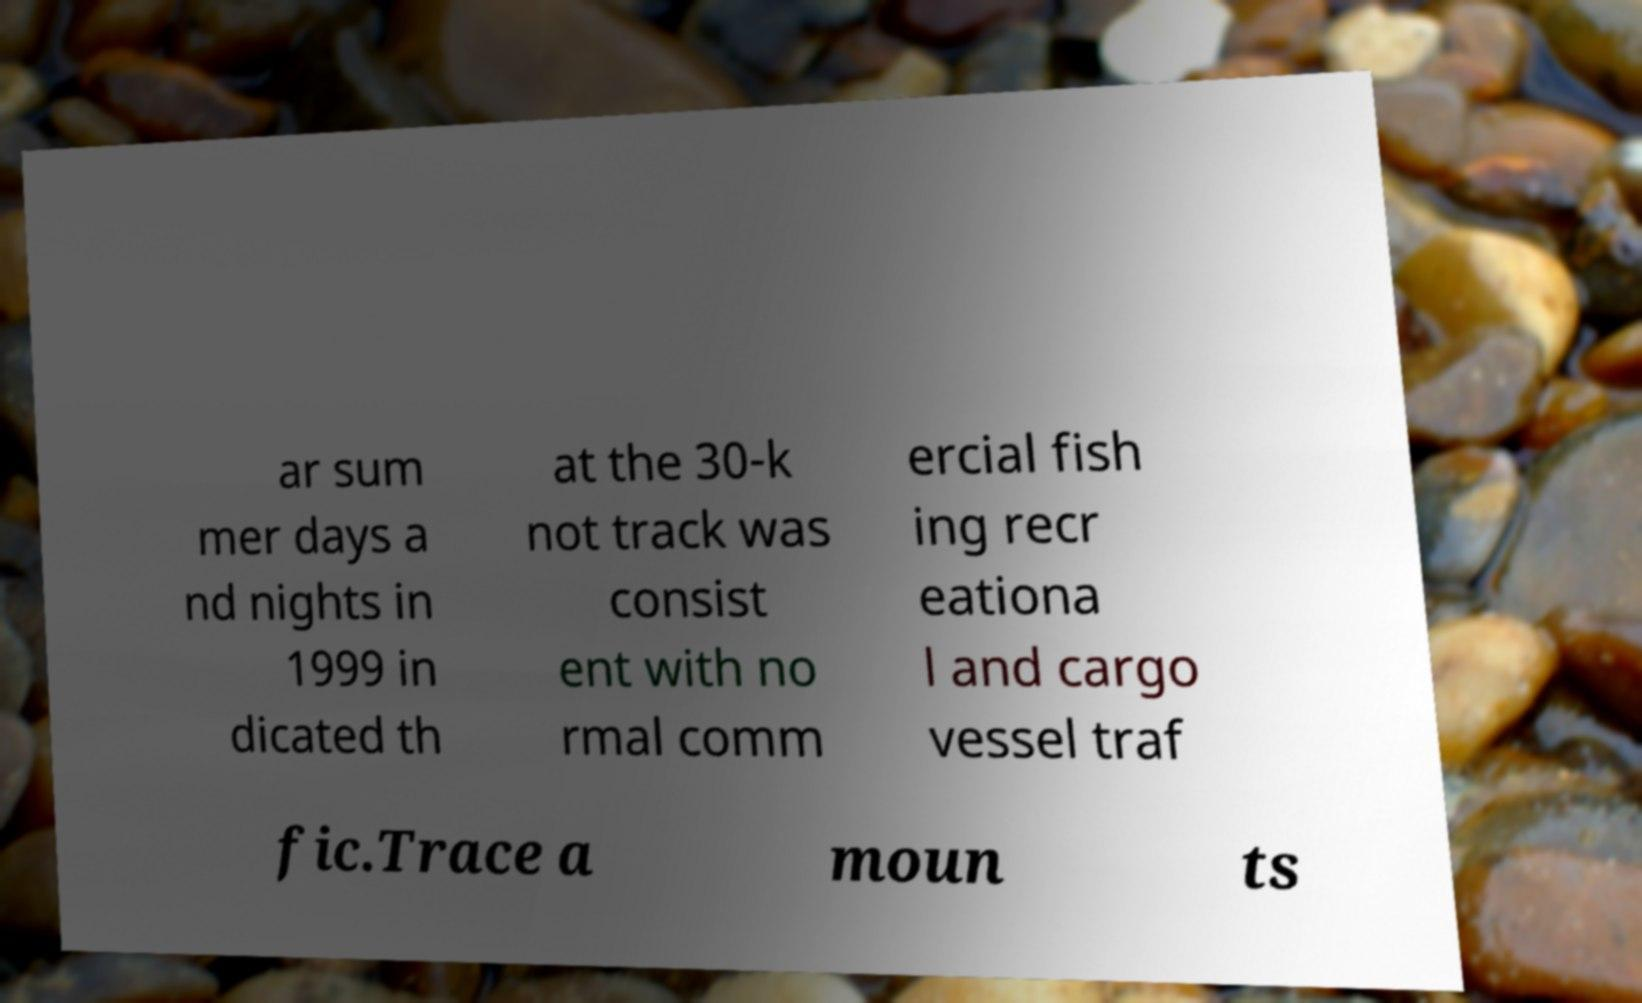Could you extract and type out the text from this image? ar sum mer days a nd nights in 1999 in dicated th at the 30-k not track was consist ent with no rmal comm ercial fish ing recr eationa l and cargo vessel traf fic.Trace a moun ts 